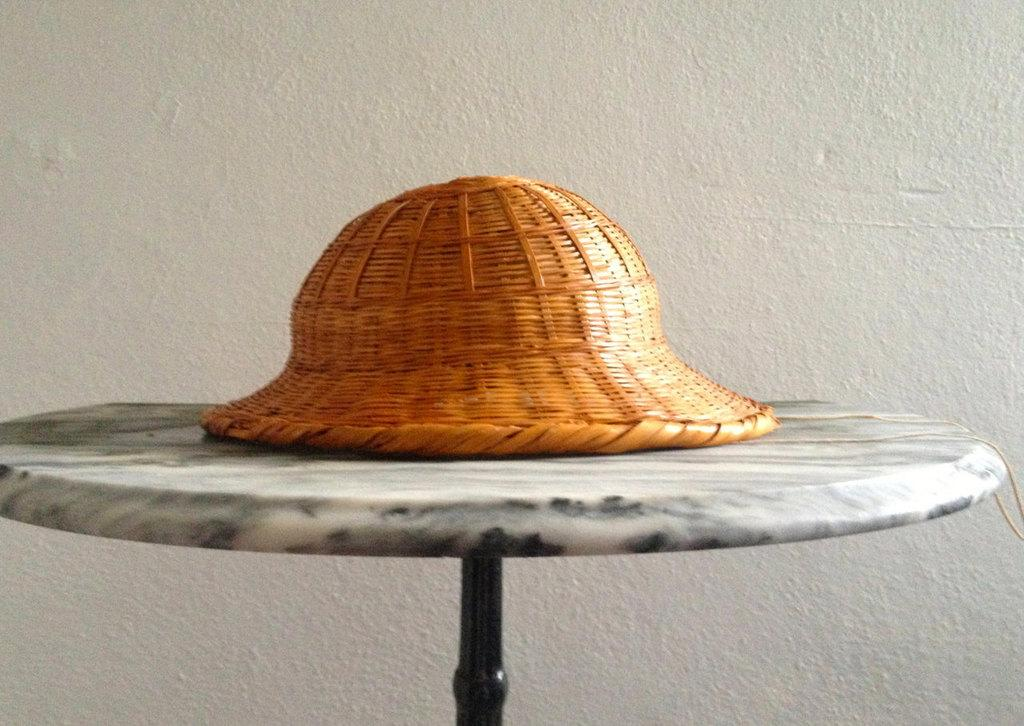What object is placed on the table in the image? There is a hat on the table in the image. What type of background can be seen in the image? There is a wall visible in the image. What type of reaction can be seen from the cat in the image? There is no cat present in the image, so it is not possible to determine any reaction from a cat. 